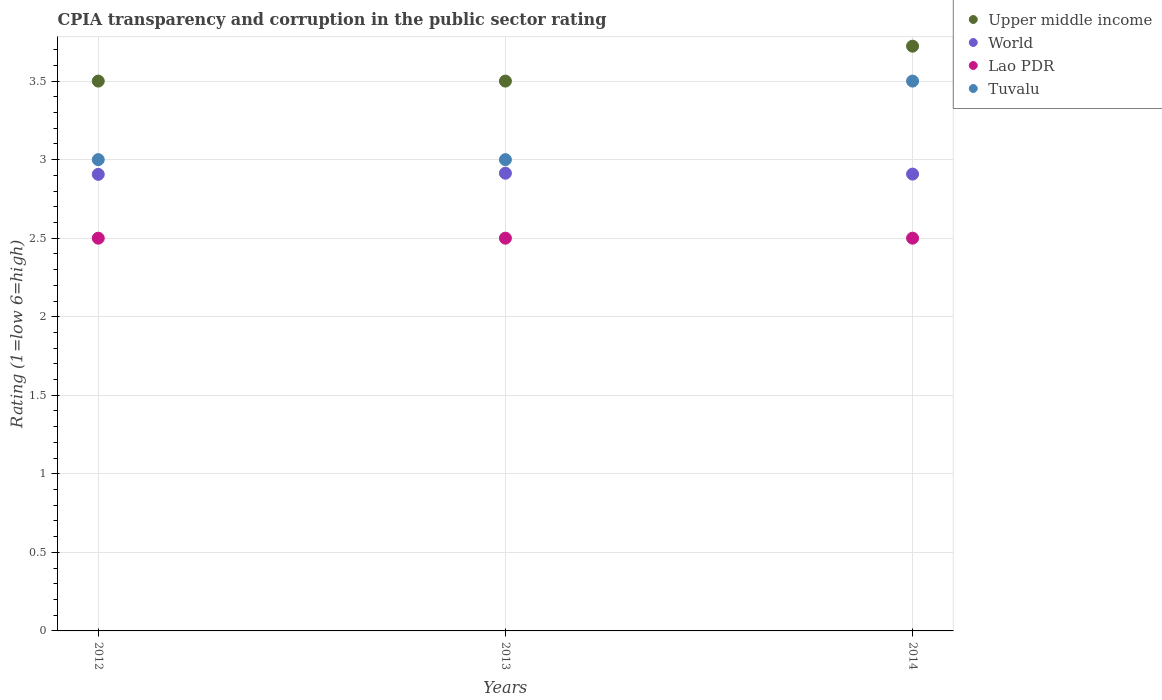How many different coloured dotlines are there?
Your answer should be compact. 4. What is the CPIA rating in World in 2012?
Ensure brevity in your answer.  2.91. Across all years, what is the maximum CPIA rating in Upper middle income?
Keep it short and to the point. 3.72. Across all years, what is the minimum CPIA rating in Lao PDR?
Your response must be concise. 2.5. What is the difference between the CPIA rating in Upper middle income in 2012 and that in 2014?
Give a very brief answer. -0.22. What is the difference between the CPIA rating in World in 2014 and the CPIA rating in Lao PDR in 2012?
Provide a succinct answer. 0.41. In the year 2012, what is the difference between the CPIA rating in World and CPIA rating in Tuvalu?
Your answer should be very brief. -0.09. What is the ratio of the CPIA rating in Lao PDR in 2012 to that in 2013?
Your answer should be compact. 1. Is the difference between the CPIA rating in World in 2013 and 2014 greater than the difference between the CPIA rating in Tuvalu in 2013 and 2014?
Make the answer very short. Yes. What is the difference between the highest and the second highest CPIA rating in Upper middle income?
Your answer should be very brief. 0.22. What is the difference between the highest and the lowest CPIA rating in Upper middle income?
Give a very brief answer. 0.22. In how many years, is the CPIA rating in Upper middle income greater than the average CPIA rating in Upper middle income taken over all years?
Offer a very short reply. 1. Is it the case that in every year, the sum of the CPIA rating in World and CPIA rating in Tuvalu  is greater than the sum of CPIA rating in Upper middle income and CPIA rating in Lao PDR?
Offer a terse response. No. Is it the case that in every year, the sum of the CPIA rating in Lao PDR and CPIA rating in World  is greater than the CPIA rating in Tuvalu?
Your answer should be compact. Yes. Does the CPIA rating in Upper middle income monotonically increase over the years?
Offer a very short reply. No. How many years are there in the graph?
Offer a very short reply. 3. What is the difference between two consecutive major ticks on the Y-axis?
Give a very brief answer. 0.5. Does the graph contain grids?
Your response must be concise. Yes. Where does the legend appear in the graph?
Make the answer very short. Top right. How many legend labels are there?
Offer a terse response. 4. How are the legend labels stacked?
Your answer should be very brief. Vertical. What is the title of the graph?
Offer a terse response. CPIA transparency and corruption in the public sector rating. What is the label or title of the Y-axis?
Offer a very short reply. Rating (1=low 6=high). What is the Rating (1=low 6=high) in Upper middle income in 2012?
Keep it short and to the point. 3.5. What is the Rating (1=low 6=high) of World in 2012?
Offer a very short reply. 2.91. What is the Rating (1=low 6=high) of Tuvalu in 2012?
Make the answer very short. 3. What is the Rating (1=low 6=high) in Upper middle income in 2013?
Your answer should be compact. 3.5. What is the Rating (1=low 6=high) in World in 2013?
Offer a very short reply. 2.91. What is the Rating (1=low 6=high) of Lao PDR in 2013?
Make the answer very short. 2.5. What is the Rating (1=low 6=high) in Upper middle income in 2014?
Your answer should be compact. 3.72. What is the Rating (1=low 6=high) of World in 2014?
Your response must be concise. 2.91. What is the Rating (1=low 6=high) in Lao PDR in 2014?
Your answer should be very brief. 2.5. What is the Rating (1=low 6=high) in Tuvalu in 2014?
Provide a short and direct response. 3.5. Across all years, what is the maximum Rating (1=low 6=high) of Upper middle income?
Provide a short and direct response. 3.72. Across all years, what is the maximum Rating (1=low 6=high) of World?
Your answer should be very brief. 2.91. Across all years, what is the maximum Rating (1=low 6=high) of Lao PDR?
Your answer should be compact. 2.5. Across all years, what is the minimum Rating (1=low 6=high) in World?
Ensure brevity in your answer.  2.91. What is the total Rating (1=low 6=high) in Upper middle income in the graph?
Your answer should be very brief. 10.72. What is the total Rating (1=low 6=high) in World in the graph?
Provide a succinct answer. 8.73. What is the difference between the Rating (1=low 6=high) of World in 2012 and that in 2013?
Give a very brief answer. -0.01. What is the difference between the Rating (1=low 6=high) of Upper middle income in 2012 and that in 2014?
Your response must be concise. -0.22. What is the difference between the Rating (1=low 6=high) of World in 2012 and that in 2014?
Your answer should be very brief. -0. What is the difference between the Rating (1=low 6=high) of Upper middle income in 2013 and that in 2014?
Ensure brevity in your answer.  -0.22. What is the difference between the Rating (1=low 6=high) of World in 2013 and that in 2014?
Give a very brief answer. 0.01. What is the difference between the Rating (1=low 6=high) in Lao PDR in 2013 and that in 2014?
Provide a succinct answer. 0. What is the difference between the Rating (1=low 6=high) in Tuvalu in 2013 and that in 2014?
Give a very brief answer. -0.5. What is the difference between the Rating (1=low 6=high) of Upper middle income in 2012 and the Rating (1=low 6=high) of World in 2013?
Make the answer very short. 0.59. What is the difference between the Rating (1=low 6=high) in Upper middle income in 2012 and the Rating (1=low 6=high) in Lao PDR in 2013?
Offer a terse response. 1. What is the difference between the Rating (1=low 6=high) in World in 2012 and the Rating (1=low 6=high) in Lao PDR in 2013?
Your answer should be very brief. 0.41. What is the difference between the Rating (1=low 6=high) in World in 2012 and the Rating (1=low 6=high) in Tuvalu in 2013?
Give a very brief answer. -0.09. What is the difference between the Rating (1=low 6=high) in Lao PDR in 2012 and the Rating (1=low 6=high) in Tuvalu in 2013?
Your answer should be very brief. -0.5. What is the difference between the Rating (1=low 6=high) of Upper middle income in 2012 and the Rating (1=low 6=high) of World in 2014?
Keep it short and to the point. 0.59. What is the difference between the Rating (1=low 6=high) of Upper middle income in 2012 and the Rating (1=low 6=high) of Lao PDR in 2014?
Your answer should be very brief. 1. What is the difference between the Rating (1=low 6=high) in Upper middle income in 2012 and the Rating (1=low 6=high) in Tuvalu in 2014?
Your response must be concise. 0. What is the difference between the Rating (1=low 6=high) in World in 2012 and the Rating (1=low 6=high) in Lao PDR in 2014?
Offer a terse response. 0.41. What is the difference between the Rating (1=low 6=high) in World in 2012 and the Rating (1=low 6=high) in Tuvalu in 2014?
Your answer should be compact. -0.59. What is the difference between the Rating (1=low 6=high) in Upper middle income in 2013 and the Rating (1=low 6=high) in World in 2014?
Offer a terse response. 0.59. What is the difference between the Rating (1=low 6=high) in World in 2013 and the Rating (1=low 6=high) in Lao PDR in 2014?
Offer a very short reply. 0.41. What is the difference between the Rating (1=low 6=high) of World in 2013 and the Rating (1=low 6=high) of Tuvalu in 2014?
Provide a short and direct response. -0.59. What is the difference between the Rating (1=low 6=high) of Lao PDR in 2013 and the Rating (1=low 6=high) of Tuvalu in 2014?
Make the answer very short. -1. What is the average Rating (1=low 6=high) in Upper middle income per year?
Give a very brief answer. 3.57. What is the average Rating (1=low 6=high) in World per year?
Keep it short and to the point. 2.91. What is the average Rating (1=low 6=high) in Tuvalu per year?
Your response must be concise. 3.17. In the year 2012, what is the difference between the Rating (1=low 6=high) in Upper middle income and Rating (1=low 6=high) in World?
Your answer should be compact. 0.59. In the year 2012, what is the difference between the Rating (1=low 6=high) of Upper middle income and Rating (1=low 6=high) of Lao PDR?
Ensure brevity in your answer.  1. In the year 2012, what is the difference between the Rating (1=low 6=high) of World and Rating (1=low 6=high) of Lao PDR?
Provide a succinct answer. 0.41. In the year 2012, what is the difference between the Rating (1=low 6=high) in World and Rating (1=low 6=high) in Tuvalu?
Make the answer very short. -0.09. In the year 2013, what is the difference between the Rating (1=low 6=high) in Upper middle income and Rating (1=low 6=high) in World?
Provide a succinct answer. 0.59. In the year 2013, what is the difference between the Rating (1=low 6=high) of Upper middle income and Rating (1=low 6=high) of Lao PDR?
Offer a terse response. 1. In the year 2013, what is the difference between the Rating (1=low 6=high) of World and Rating (1=low 6=high) of Lao PDR?
Provide a succinct answer. 0.41. In the year 2013, what is the difference between the Rating (1=low 6=high) of World and Rating (1=low 6=high) of Tuvalu?
Offer a very short reply. -0.09. In the year 2014, what is the difference between the Rating (1=low 6=high) in Upper middle income and Rating (1=low 6=high) in World?
Your answer should be very brief. 0.81. In the year 2014, what is the difference between the Rating (1=low 6=high) of Upper middle income and Rating (1=low 6=high) of Lao PDR?
Offer a very short reply. 1.22. In the year 2014, what is the difference between the Rating (1=low 6=high) in Upper middle income and Rating (1=low 6=high) in Tuvalu?
Offer a very short reply. 0.22. In the year 2014, what is the difference between the Rating (1=low 6=high) in World and Rating (1=low 6=high) in Lao PDR?
Offer a terse response. 0.41. In the year 2014, what is the difference between the Rating (1=low 6=high) of World and Rating (1=low 6=high) of Tuvalu?
Provide a succinct answer. -0.59. What is the ratio of the Rating (1=low 6=high) of Tuvalu in 2012 to that in 2013?
Make the answer very short. 1. What is the ratio of the Rating (1=low 6=high) in Upper middle income in 2012 to that in 2014?
Ensure brevity in your answer.  0.94. What is the ratio of the Rating (1=low 6=high) of Upper middle income in 2013 to that in 2014?
Your answer should be very brief. 0.94. What is the difference between the highest and the second highest Rating (1=low 6=high) of Upper middle income?
Your response must be concise. 0.22. What is the difference between the highest and the second highest Rating (1=low 6=high) of World?
Offer a very short reply. 0.01. What is the difference between the highest and the lowest Rating (1=low 6=high) in Upper middle income?
Give a very brief answer. 0.22. What is the difference between the highest and the lowest Rating (1=low 6=high) of World?
Your response must be concise. 0.01. 